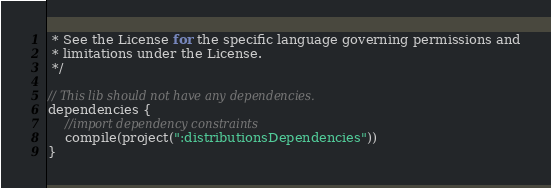Convert code to text. <code><loc_0><loc_0><loc_500><loc_500><_Kotlin_> * See the License for the specific language governing permissions and
 * limitations under the License.
 */

// This lib should not have any dependencies.
dependencies {
    //import dependency constraints
    compile(project(":distributionsDependencies"))
}
</code> 